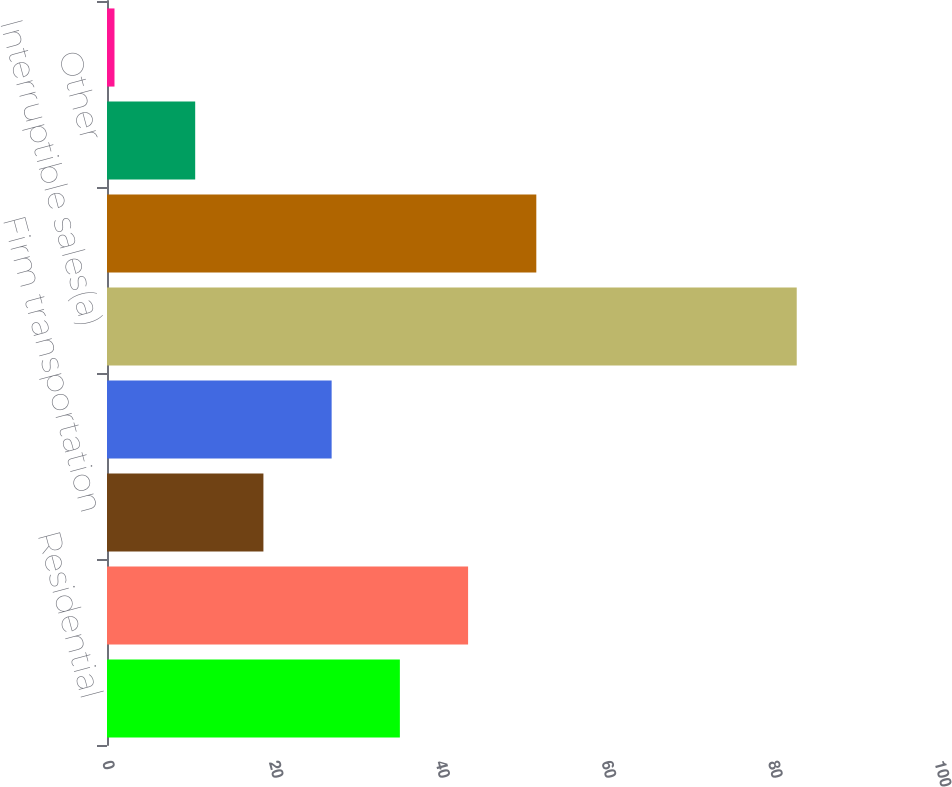<chart> <loc_0><loc_0><loc_500><loc_500><bar_chart><fcel>Residential<fcel>General<fcel>Firm transportation<fcel>Total firm sales and<fcel>Interruptible sales(a)<fcel>Generation plants<fcel>Other<fcel>Total<nl><fcel>35.2<fcel>43.4<fcel>18.8<fcel>27<fcel>82.9<fcel>51.6<fcel>10.6<fcel>0.9<nl></chart> 